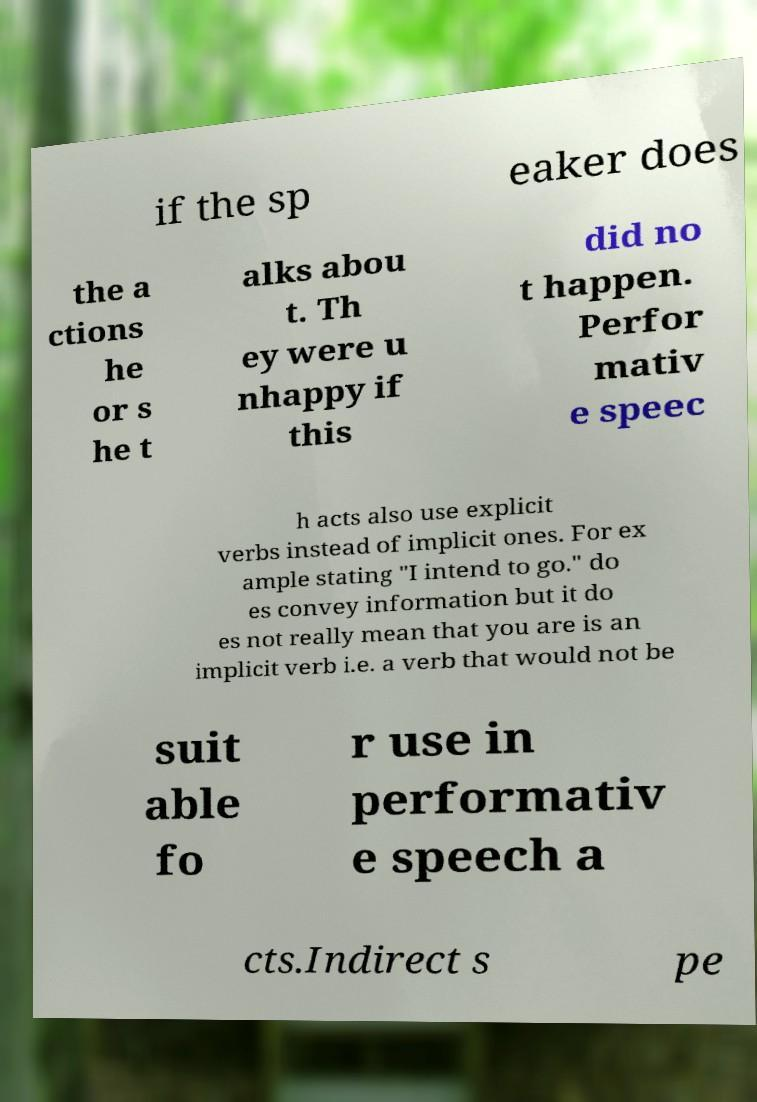I need the written content from this picture converted into text. Can you do that? if the sp eaker does the a ctions he or s he t alks abou t. Th ey were u nhappy if this did no t happen. Perfor mativ e speec h acts also use explicit verbs instead of implicit ones. For ex ample stating "I intend to go." do es convey information but it do es not really mean that you are is an implicit verb i.e. a verb that would not be suit able fo r use in performativ e speech a cts.Indirect s pe 